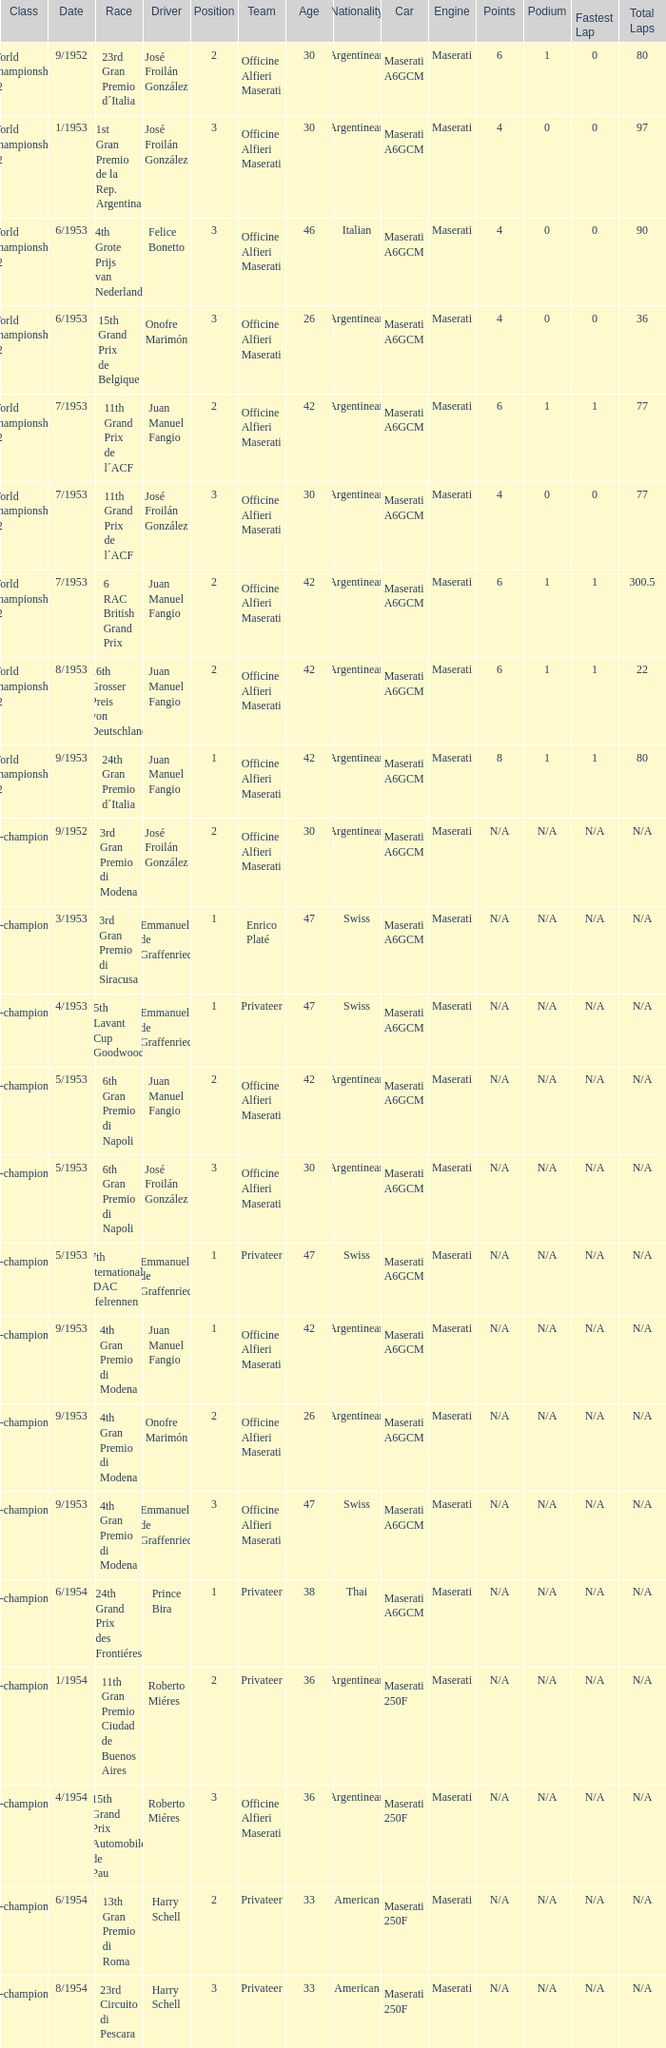Could you parse the entire table as a dict? {'header': ['Class', 'Date', 'Race', 'Driver', 'Position', 'Team', 'Age', 'Nationality', 'Car', 'Engine', 'Points', 'Podium', 'Fastest Lap', 'Total Laps'], 'rows': [['World Championship F2', '9/1952', '23rd Gran Premio d´Italia', 'José Froilán González', '2', 'Officine Alfieri Maserati', '30', 'Argentinean', 'Maserati A6GCM', 'Maserati', '6', '1', '0', '80'], ['World Championship F2', '1/1953', '1st Gran Premio de la Rep. Argentina', 'José Froilán González', '3', 'Officine Alfieri Maserati', '30', 'Argentinean', 'Maserati A6GCM', 'Maserati', '4', '0', '0', '97'], ['World Championship F2', '6/1953', '4th Grote Prijs van Nederland', 'Felice Bonetto', '3', 'Officine Alfieri Maserati', '46', 'Italian', 'Maserati A6GCM', 'Maserati', '4', '0', '0', '90'], ['World Championship F2', '6/1953', '15th Grand Prix de Belgique', 'Onofre Marimón', '3', 'Officine Alfieri Maserati', '26', 'Argentinean', 'Maserati A6GCM', 'Maserati', '4', '0', '0', '36'], ['World Championship F2', '7/1953', '11th Grand Prix de l´ACF', 'Juan Manuel Fangio', '2', 'Officine Alfieri Maserati', '42', 'Argentinean', 'Maserati A6GCM', 'Maserati', '6', '1', '1', '77'], ['World Championship F2', '7/1953', '11th Grand Prix de l´ACF', 'José Froilán González', '3', 'Officine Alfieri Maserati', '30', 'Argentinean', 'Maserati A6GCM', 'Maserati', '4', '0', '0', '77'], ['World Championship F2', '7/1953', '6 RAC British Grand Prix', 'Juan Manuel Fangio', '2', 'Officine Alfieri Maserati', '42', 'Argentinean', 'Maserati A6GCM', 'Maserati', '6', '1', '1', '300.5'], ['World Championship F2', '8/1953', '16th Grosser Preis von Deutschland', 'Juan Manuel Fangio', '2', 'Officine Alfieri Maserati', '42', 'Argentinean', 'Maserati A6GCM', 'Maserati', '6', '1', '1', '22'], ['World Championship F2', '9/1953', '24th Gran Premio d´Italia', 'Juan Manuel Fangio', '1', 'Officine Alfieri Maserati', '42', 'Argentinean', 'Maserati A6GCM', 'Maserati', '8', '1', '1', '80'], ['Non-championship F2', '9/1952', '3rd Gran Premio di Modena', 'José Froilán González', '2', 'Officine Alfieri Maserati', '30', 'Argentinean', 'Maserati A6GCM', 'Maserati', 'N/A', 'N/A', 'N/A', 'N/A'], ['Non-championship F2', '3/1953', '3rd Gran Premio di Siracusa', 'Emmanuel de Graffenried', '1', 'Enrico Platé', '47', 'Swiss', 'Maserati A6GCM', 'Maserati', 'N/A', 'N/A', 'N/A', 'N/A'], ['Non-championship F2', '4/1953', '5th Lavant Cup Goodwood', 'Emmanuel de Graffenried', '1', 'Privateer', '47', 'Swiss', 'Maserati A6GCM', 'Maserati', 'N/A', 'N/A', 'N/A', 'N/A'], ['Non-championship F2', '5/1953', '6th Gran Premio di Napoli', 'Juan Manuel Fangio', '2', 'Officine Alfieri Maserati', '42', 'Argentinean', 'Maserati A6GCM', 'Maserati', 'N/A', 'N/A', 'N/A', 'N/A'], ['Non-championship F2', '5/1953', '6th Gran Premio di Napoli', 'José Froilán González', '3', 'Officine Alfieri Maserati', '30', 'Argentinean', 'Maserati A6GCM', 'Maserati', 'N/A', 'N/A', 'N/A', 'N/A'], ['Non-championship F2', '5/1953', '17th Internationales ADAC Eifelrennen', 'Emmanuel de Graffenried', '1', 'Privateer', '47', 'Swiss', 'Maserati A6GCM', 'Maserati', 'N/A', 'N/A', 'N/A', 'N/A'], ['Non-championship F2', '9/1953', '4th Gran Premio di Modena', 'Juan Manuel Fangio', '1', 'Officine Alfieri Maserati', '42', 'Argentinean', 'Maserati A6GCM', 'Maserati', 'N/A', 'N/A', 'N/A', 'N/A'], ['Non-championship F2', '9/1953', '4th Gran Premio di Modena', 'Onofre Marimón', '2', 'Officine Alfieri Maserati', '26', 'Argentinean', 'Maserati A6GCM', 'Maserati', 'N/A', 'N/A', 'N/A', 'N/A'], ['Non-championship F2', '9/1953', '4th Gran Premio di Modena', 'Emmanuel de Graffenried', '3', 'Officine Alfieri Maserati', '47', 'Swiss', 'Maserati A6GCM', 'Maserati', 'N/A', 'N/A', 'N/A', 'N/A'], ['(Non-championship) F2', '6/1954', '24th Grand Prix des Frontiéres', 'Prince Bira', '1', 'Privateer', '38', 'Thai', 'Maserati A6GCM', 'Maserati', 'N/A', 'N/A', 'N/A', 'N/A'], ['Non-championship F1', '1/1954', '11th Gran Premio Ciudad de Buenos Aires', 'Roberto Miéres', '2', 'Privateer', '36', 'Argentinean', 'Maserati 250F', 'Maserati', 'N/A', 'N/A', 'N/A', 'N/A'], ['Non-championship F1', '4/1954', '15th Grand Prix Automobile de Pau', 'Roberto Miéres', '3', 'Officine Alfieri Maserati', '36', 'Argentinean', 'Maserati 250F', 'Maserati', 'N/A', 'N/A', 'N/A', 'N/A'], ['Non-championship F1', '6/1954', '13th Gran Premio di Roma', 'Harry Schell', '2', 'Privateer', '33', 'American', 'Maserati 250F', 'Maserati', 'N/A', 'N/A', 'N/A', 'N/A'], ['Non-championship F1', '8/1954', '23rd Circuito di Pescara', 'Harry Schell', '3', 'Privateer', '33', 'American', 'Maserati 250F', 'Maserati', 'N/A', 'N/A', 'N/A', 'N/A']]} What driver has a team of officine alfieri maserati and belongs to the class of non-championship f2 and has a position of 2, as well as a date of 9/1952? José Froilán González. 